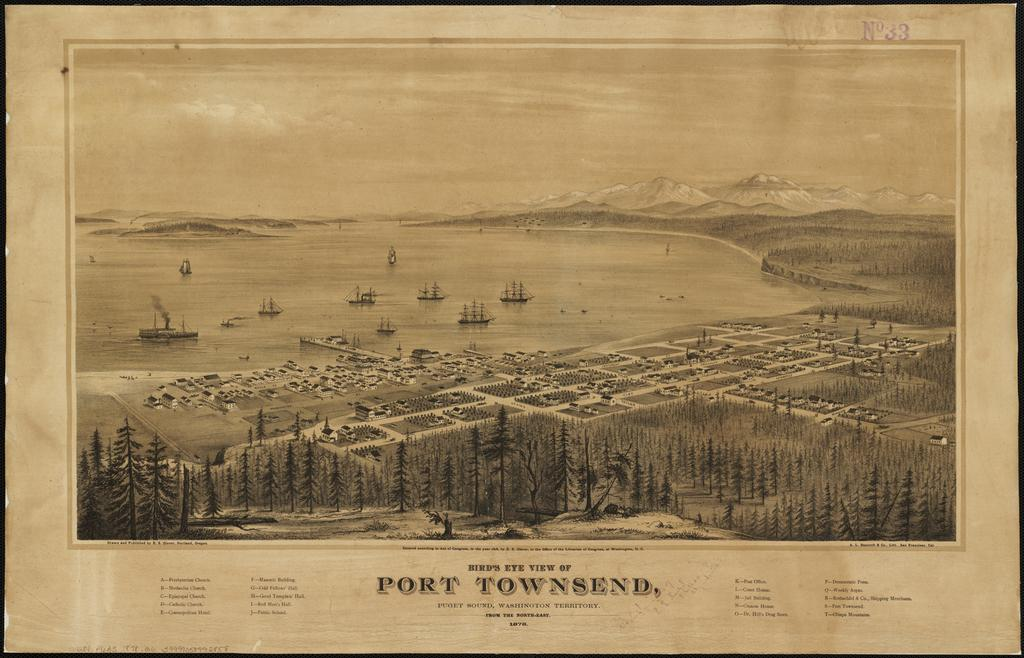<image>
Summarize the visual content of the image. Poster for a town which the words "Port Townsend" on the bottom. 